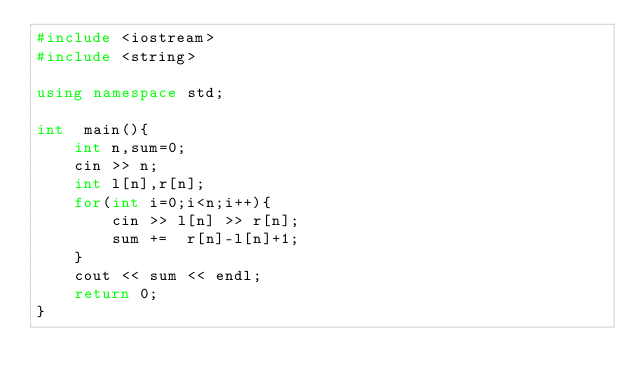Convert code to text. <code><loc_0><loc_0><loc_500><loc_500><_C++_>#include <iostream>
#include <string>

using namespace std;

int  main(){
    int n,sum=0;
    cin >> n;
    int l[n],r[n];
    for(int i=0;i<n;i++){
        cin >> l[n] >> r[n];
        sum +=  r[n]-l[n]+1;
    }
    cout << sum << endl;
    return 0;
}</code> 